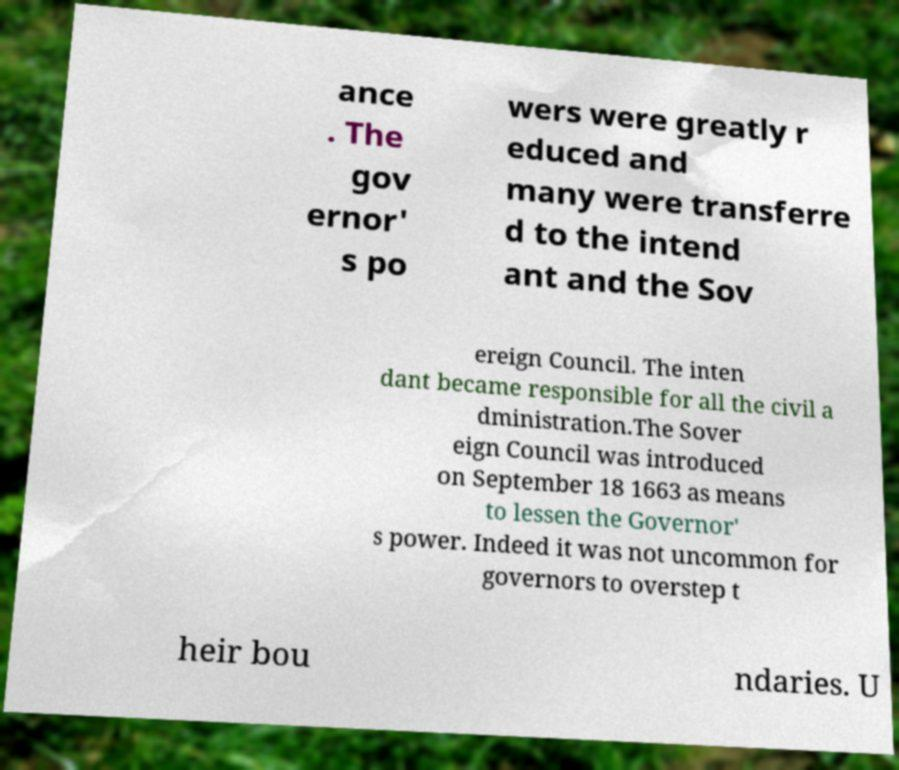I need the written content from this picture converted into text. Can you do that? ance . The gov ernor' s po wers were greatly r educed and many were transferre d to the intend ant and the Sov ereign Council. The inten dant became responsible for all the civil a dministration.The Sover eign Council was introduced on September 18 1663 as means to lessen the Governor' s power. Indeed it was not uncommon for governors to overstep t heir bou ndaries. U 